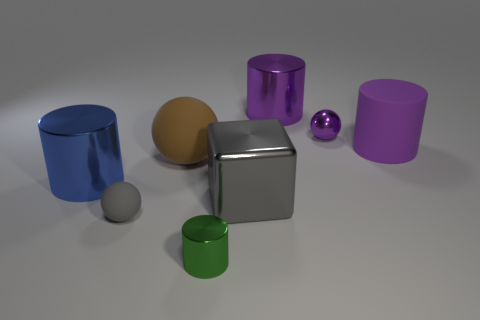Add 1 gray objects. How many objects exist? 9 Subtract all blocks. How many objects are left? 7 Add 5 large purple matte cylinders. How many large purple matte cylinders are left? 6 Add 2 gray things. How many gray things exist? 4 Subtract 1 gray spheres. How many objects are left? 7 Subtract all matte balls. Subtract all purple rubber cylinders. How many objects are left? 5 